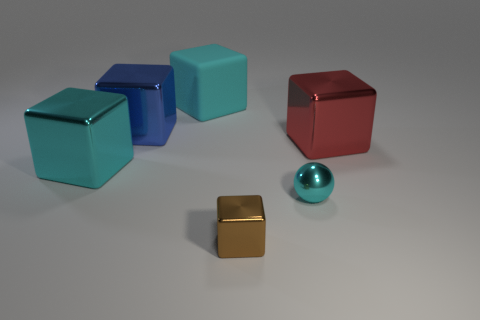Subtract all cyan rubber cubes. How many cubes are left? 4 Subtract all blue cubes. How many cubes are left? 4 Subtract all green cubes. Subtract all purple spheres. How many cubes are left? 5 Add 1 big red metallic cubes. How many objects exist? 7 Subtract all cubes. How many objects are left? 1 Subtract all large cyan rubber objects. Subtract all small purple metal spheres. How many objects are left? 5 Add 4 small cyan metal things. How many small cyan metal things are left? 5 Add 4 tiny shiny things. How many tiny shiny things exist? 6 Subtract 0 gray cylinders. How many objects are left? 6 